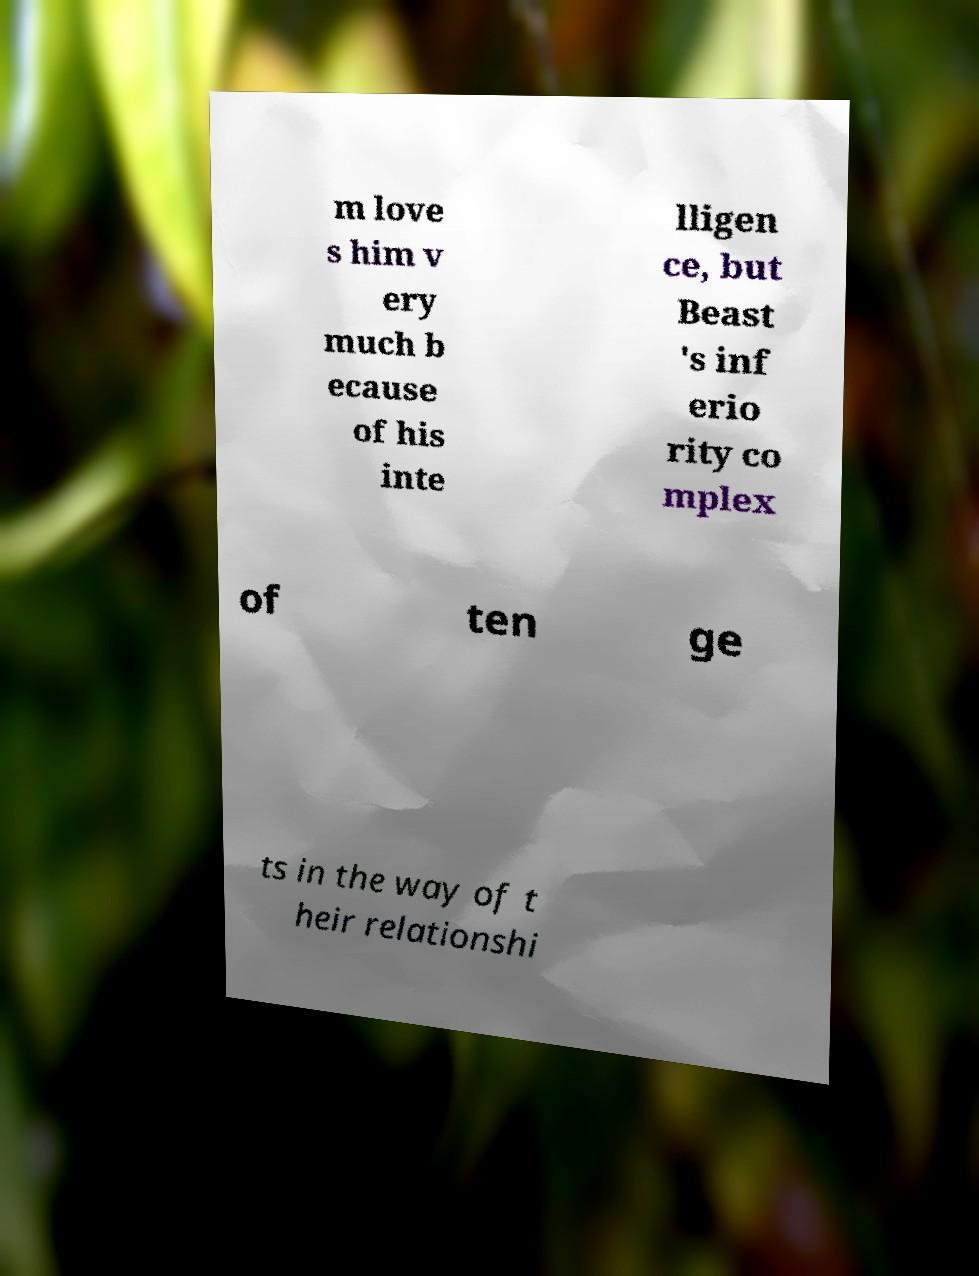Can you accurately transcribe the text from the provided image for me? m love s him v ery much b ecause of his inte lligen ce, but Beast 's inf erio rity co mplex of ten ge ts in the way of t heir relationshi 